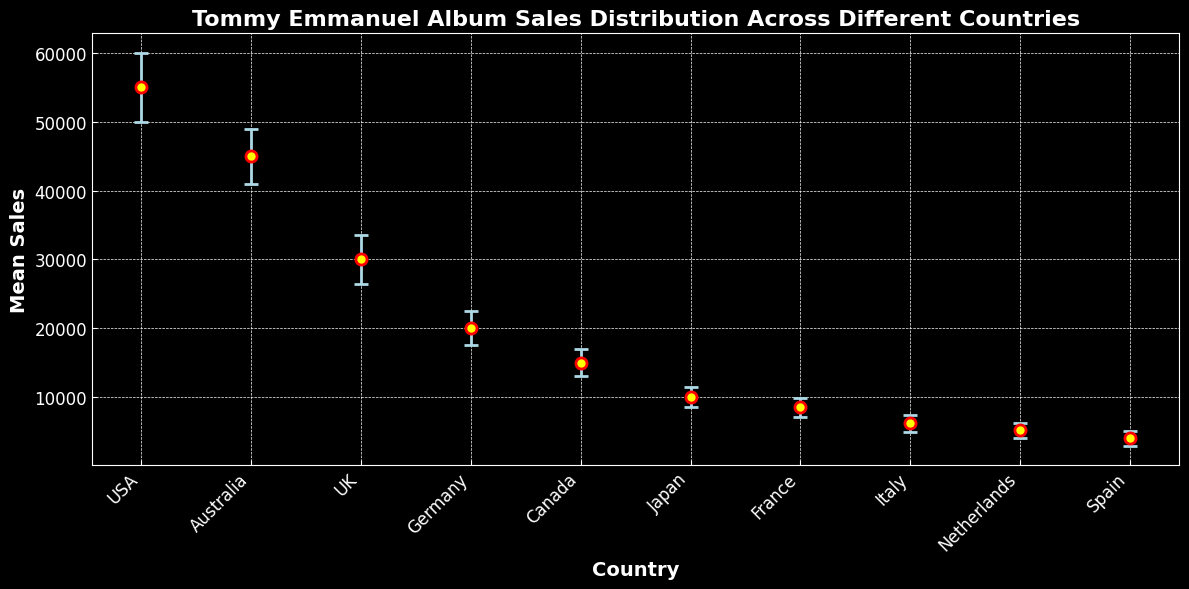What is the country with the highest mean album sales? The country with the highest mean album sales has the tallest dot on the chart. Here, the USA has the highest mean sales dot.
Answer: USA What is the difference in mean sales between the country with the highest and lowest sales? The highest mean sales are in the USA (55,000), and the lowest are in Spain (4,000). Subtract the lowest mean sales from the highest mean sales: 55,000 - 4,000.
Answer: 51,000 Which two countries have the smallest mean sales? Looking at the chart, Spain and the Netherlands have the lowest dots, indicating the smallest mean sales.
Answer: Spain and Netherlands How much higher are the mean sales in the USA compared to those in Australia? The mean sales in the USA are 55,000, and in Australia, they are 45,000. Subtract the mean sales in Australia from those in the USA: 55,000 - 45,000.
Answer: 10,000 What is the mean sales difference between the top two selling countries? The top two selling countries are the USA (55,000) and Australia (45,000). Subtract the mean sales in Australia from those in the USA: 55,000 - 45,000.
Answer: 10,000 Which country has the largest standard deviation in album sales, and what is its value? The standard deviation can be identified by looking at the size of the error bars. The USA has the largest error bars and hence the largest standard deviation, which is 5,000.
Answer: USA, 5,000 What is the combined mean album sales of Germany and Japan? The mean sales in Germany are 20,000 and in Japan are 10,000. Add these two together: 20,000 + 10,000.
Answer: 30,000 Which country shows the smallest variability in album sales and what is its standard deviation value? The country with the smallest error bars has the smallest standard deviation. Spain has the smallest standard deviation with an error bar value of 1,050.
Answer: Spain, 1,050 Which three countries have a mean album sales greater than 30,000? Looking at the chart, the countries with mean sales above 30,000 are the USA (55,000), Australia (45,000), and the UK (30,000).
Answer: USA, Australia, UK What is the mean value of the album sales for the UK and Canada? The mean sales for the UK are 30,000 and for Canada are 15,000. Find their average: (30,000 + 15,000) / 2.
Answer: 22,500 